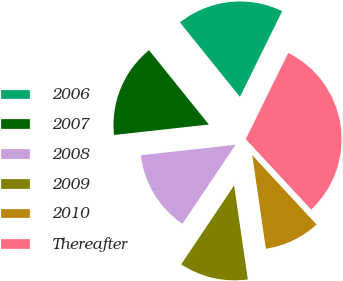<chart> <loc_0><loc_0><loc_500><loc_500><pie_chart><fcel>2006<fcel>2007<fcel>2008<fcel>2009<fcel>2010<fcel>Thereafter<nl><fcel>18.08%<fcel>15.96%<fcel>13.84%<fcel>11.72%<fcel>9.6%<fcel>30.81%<nl></chart> 